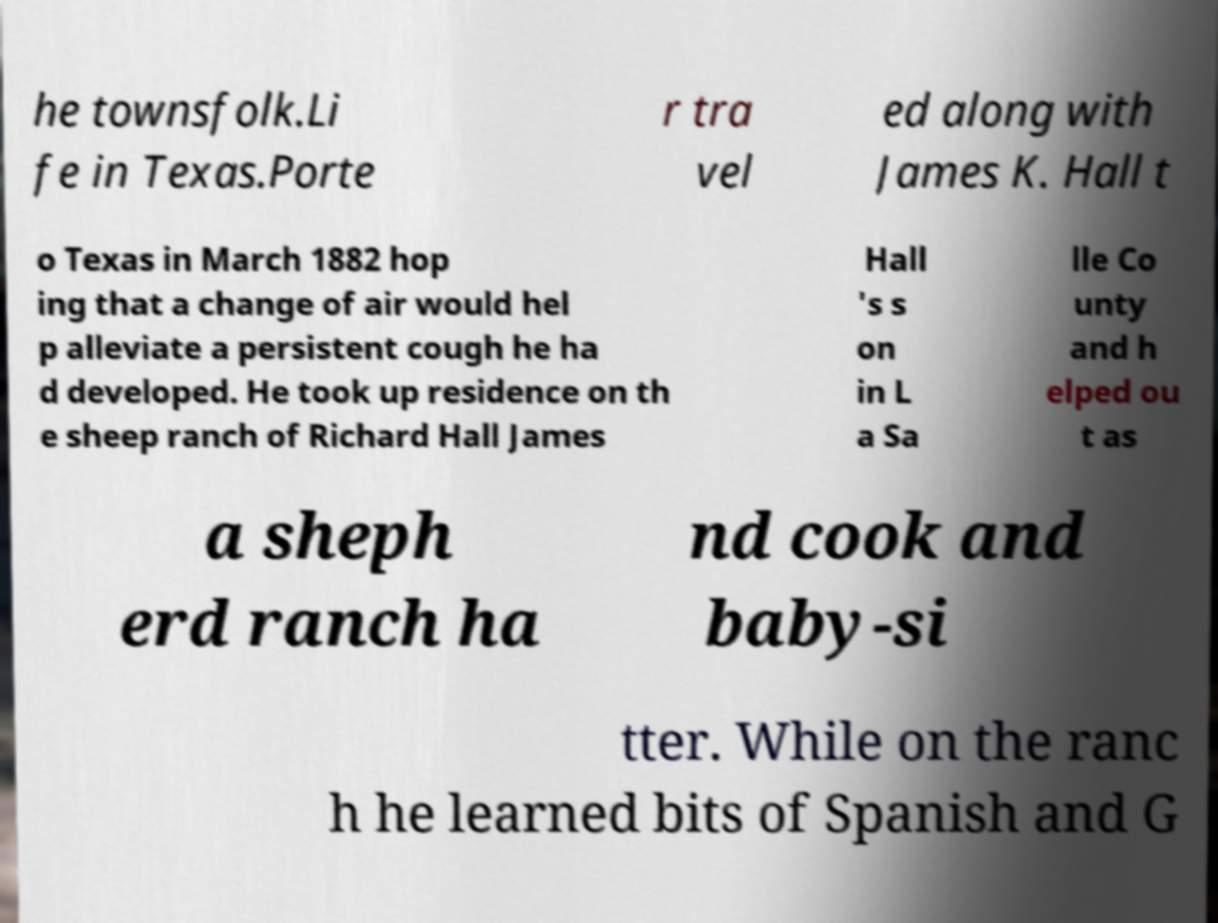Can you read and provide the text displayed in the image?This photo seems to have some interesting text. Can you extract and type it out for me? he townsfolk.Li fe in Texas.Porte r tra vel ed along with James K. Hall t o Texas in March 1882 hop ing that a change of air would hel p alleviate a persistent cough he ha d developed. He took up residence on th e sheep ranch of Richard Hall James Hall 's s on in L a Sa lle Co unty and h elped ou t as a sheph erd ranch ha nd cook and baby-si tter. While on the ranc h he learned bits of Spanish and G 